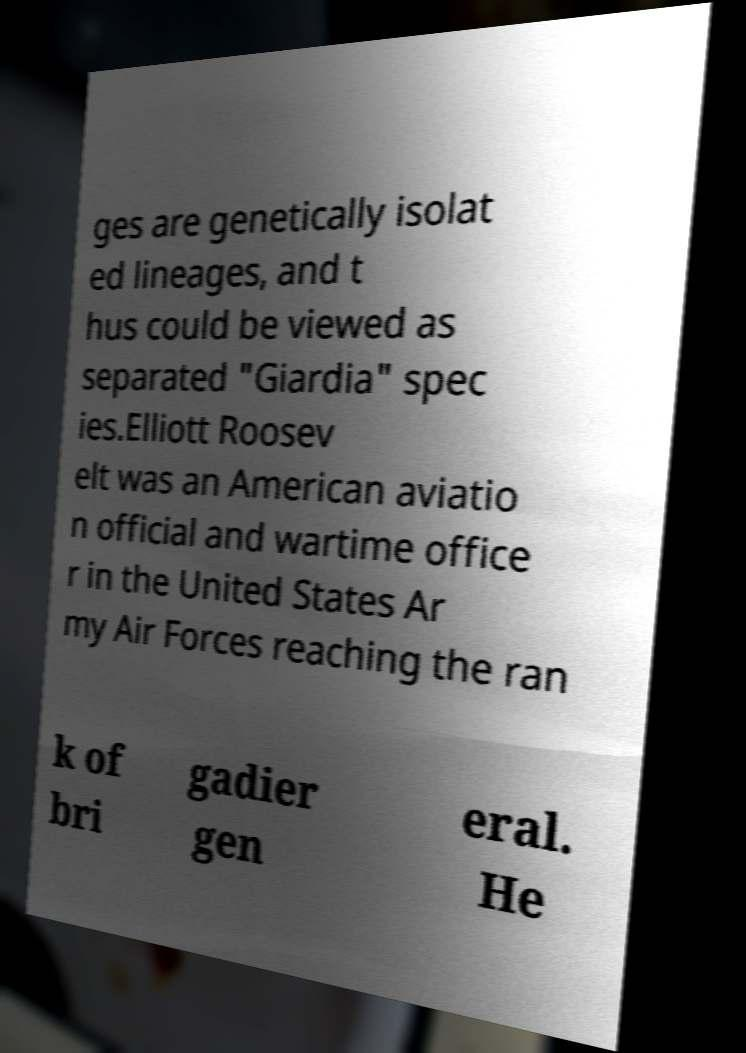Can you accurately transcribe the text from the provided image for me? ges are genetically isolat ed lineages, and t hus could be viewed as separated "Giardia" spec ies.Elliott Roosev elt was an American aviatio n official and wartime office r in the United States Ar my Air Forces reaching the ran k of bri gadier gen eral. He 